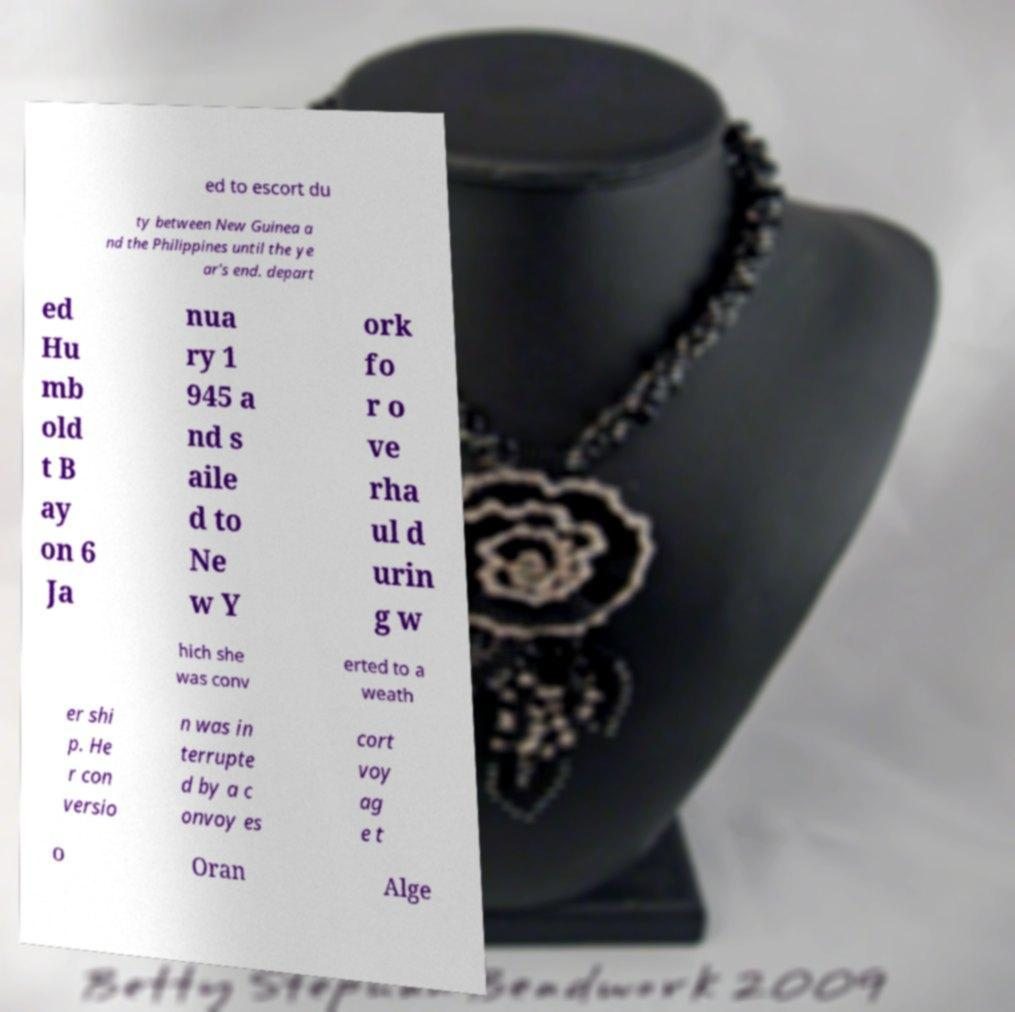I need the written content from this picture converted into text. Can you do that? ed to escort du ty between New Guinea a nd the Philippines until the ye ar's end. depart ed Hu mb old t B ay on 6 Ja nua ry 1 945 a nd s aile d to Ne w Y ork fo r o ve rha ul d urin g w hich she was conv erted to a weath er shi p. He r con versio n was in terrupte d by a c onvoy es cort voy ag e t o Oran Alge 